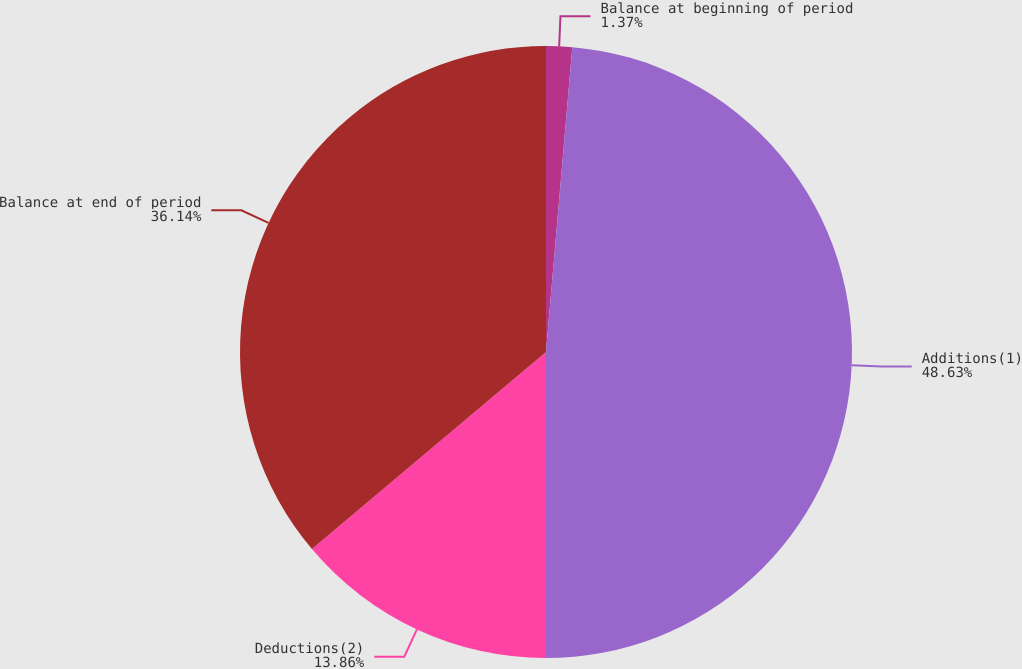<chart> <loc_0><loc_0><loc_500><loc_500><pie_chart><fcel>Balance at beginning of period<fcel>Additions(1)<fcel>Deductions(2)<fcel>Balance at end of period<nl><fcel>1.37%<fcel>48.63%<fcel>13.86%<fcel>36.14%<nl></chart> 